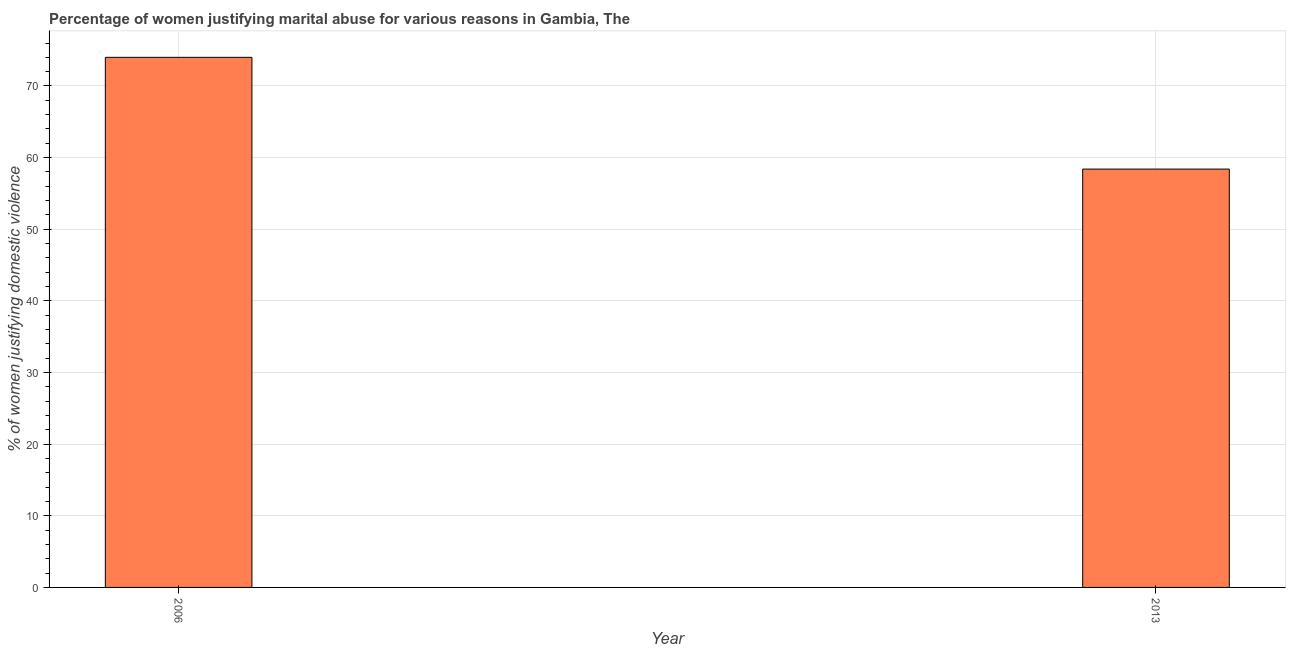Does the graph contain any zero values?
Your response must be concise. No. Does the graph contain grids?
Offer a very short reply. Yes. What is the title of the graph?
Provide a succinct answer. Percentage of women justifying marital abuse for various reasons in Gambia, The. What is the label or title of the Y-axis?
Your answer should be compact. % of women justifying domestic violence. What is the percentage of women justifying marital abuse in 2013?
Make the answer very short. 58.4. Across all years, what is the minimum percentage of women justifying marital abuse?
Provide a succinct answer. 58.4. In which year was the percentage of women justifying marital abuse maximum?
Offer a very short reply. 2006. In which year was the percentage of women justifying marital abuse minimum?
Your answer should be very brief. 2013. What is the sum of the percentage of women justifying marital abuse?
Provide a short and direct response. 132.4. What is the average percentage of women justifying marital abuse per year?
Offer a very short reply. 66.2. What is the median percentage of women justifying marital abuse?
Make the answer very short. 66.2. What is the ratio of the percentage of women justifying marital abuse in 2006 to that in 2013?
Keep it short and to the point. 1.27. Is the percentage of women justifying marital abuse in 2006 less than that in 2013?
Your answer should be very brief. No. In how many years, is the percentage of women justifying marital abuse greater than the average percentage of women justifying marital abuse taken over all years?
Offer a terse response. 1. Are all the bars in the graph horizontal?
Make the answer very short. No. Are the values on the major ticks of Y-axis written in scientific E-notation?
Offer a very short reply. No. What is the % of women justifying domestic violence of 2013?
Your answer should be very brief. 58.4. What is the difference between the % of women justifying domestic violence in 2006 and 2013?
Provide a succinct answer. 15.6. What is the ratio of the % of women justifying domestic violence in 2006 to that in 2013?
Provide a short and direct response. 1.27. 